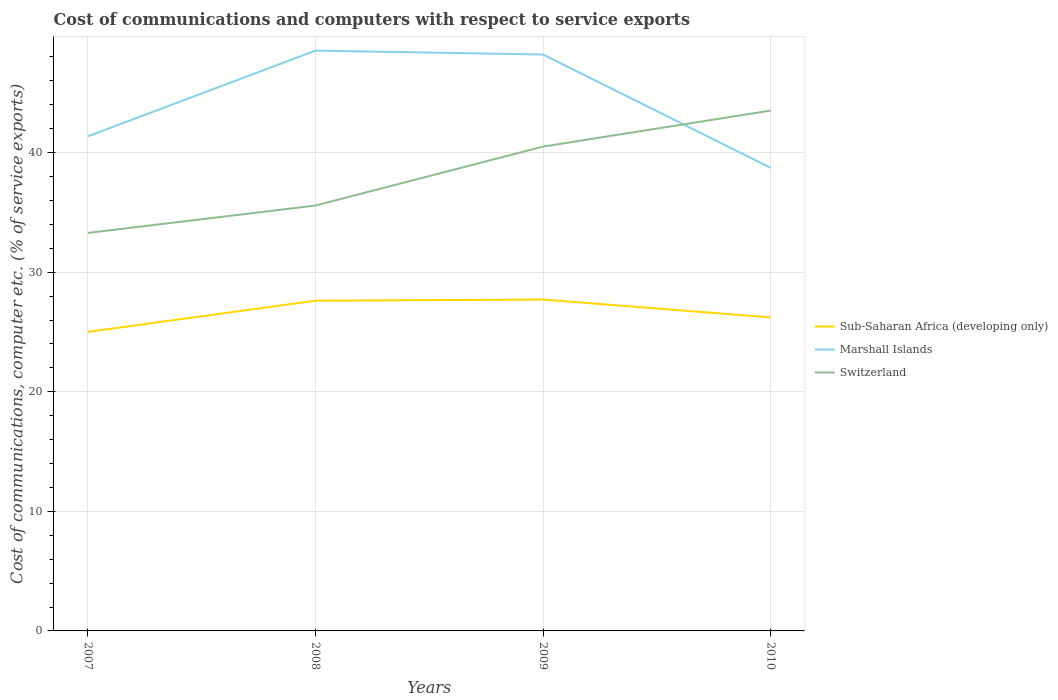How many different coloured lines are there?
Offer a terse response. 3. Across all years, what is the maximum cost of communications and computers in Sub-Saharan Africa (developing only)?
Make the answer very short. 25.01. In which year was the cost of communications and computers in Switzerland maximum?
Your answer should be compact. 2007. What is the total cost of communications and computers in Marshall Islands in the graph?
Give a very brief answer. 9.48. What is the difference between the highest and the second highest cost of communications and computers in Switzerland?
Offer a very short reply. 10.23. What is the difference between the highest and the lowest cost of communications and computers in Switzerland?
Your answer should be very brief. 2. Is the cost of communications and computers in Marshall Islands strictly greater than the cost of communications and computers in Switzerland over the years?
Give a very brief answer. No. How many lines are there?
Provide a short and direct response. 3. How many years are there in the graph?
Offer a very short reply. 4. What is the difference between two consecutive major ticks on the Y-axis?
Provide a short and direct response. 10. Does the graph contain any zero values?
Provide a succinct answer. No. How many legend labels are there?
Make the answer very short. 3. What is the title of the graph?
Give a very brief answer. Cost of communications and computers with respect to service exports. What is the label or title of the X-axis?
Provide a succinct answer. Years. What is the label or title of the Y-axis?
Keep it short and to the point. Cost of communications, computer etc. (% of service exports). What is the Cost of communications, computer etc. (% of service exports) of Sub-Saharan Africa (developing only) in 2007?
Your response must be concise. 25.01. What is the Cost of communications, computer etc. (% of service exports) in Marshall Islands in 2007?
Offer a very short reply. 41.36. What is the Cost of communications, computer etc. (% of service exports) in Switzerland in 2007?
Your answer should be very brief. 33.29. What is the Cost of communications, computer etc. (% of service exports) in Sub-Saharan Africa (developing only) in 2008?
Offer a very short reply. 27.62. What is the Cost of communications, computer etc. (% of service exports) in Marshall Islands in 2008?
Your answer should be very brief. 48.53. What is the Cost of communications, computer etc. (% of service exports) of Switzerland in 2008?
Give a very brief answer. 35.58. What is the Cost of communications, computer etc. (% of service exports) of Sub-Saharan Africa (developing only) in 2009?
Provide a short and direct response. 27.71. What is the Cost of communications, computer etc. (% of service exports) of Marshall Islands in 2009?
Your answer should be compact. 48.2. What is the Cost of communications, computer etc. (% of service exports) of Switzerland in 2009?
Provide a short and direct response. 40.51. What is the Cost of communications, computer etc. (% of service exports) of Sub-Saharan Africa (developing only) in 2010?
Offer a terse response. 26.22. What is the Cost of communications, computer etc. (% of service exports) in Marshall Islands in 2010?
Your answer should be very brief. 38.73. What is the Cost of communications, computer etc. (% of service exports) of Switzerland in 2010?
Provide a short and direct response. 43.52. Across all years, what is the maximum Cost of communications, computer etc. (% of service exports) of Sub-Saharan Africa (developing only)?
Give a very brief answer. 27.71. Across all years, what is the maximum Cost of communications, computer etc. (% of service exports) of Marshall Islands?
Make the answer very short. 48.53. Across all years, what is the maximum Cost of communications, computer etc. (% of service exports) in Switzerland?
Ensure brevity in your answer.  43.52. Across all years, what is the minimum Cost of communications, computer etc. (% of service exports) of Sub-Saharan Africa (developing only)?
Your response must be concise. 25.01. Across all years, what is the minimum Cost of communications, computer etc. (% of service exports) in Marshall Islands?
Provide a short and direct response. 38.73. Across all years, what is the minimum Cost of communications, computer etc. (% of service exports) in Switzerland?
Offer a terse response. 33.29. What is the total Cost of communications, computer etc. (% of service exports) of Sub-Saharan Africa (developing only) in the graph?
Provide a succinct answer. 106.56. What is the total Cost of communications, computer etc. (% of service exports) in Marshall Islands in the graph?
Make the answer very short. 176.83. What is the total Cost of communications, computer etc. (% of service exports) of Switzerland in the graph?
Offer a terse response. 152.89. What is the difference between the Cost of communications, computer etc. (% of service exports) in Sub-Saharan Africa (developing only) in 2007 and that in 2008?
Provide a short and direct response. -2.61. What is the difference between the Cost of communications, computer etc. (% of service exports) of Marshall Islands in 2007 and that in 2008?
Give a very brief answer. -7.17. What is the difference between the Cost of communications, computer etc. (% of service exports) in Switzerland in 2007 and that in 2008?
Offer a very short reply. -2.29. What is the difference between the Cost of communications, computer etc. (% of service exports) of Sub-Saharan Africa (developing only) in 2007 and that in 2009?
Your answer should be compact. -2.71. What is the difference between the Cost of communications, computer etc. (% of service exports) in Marshall Islands in 2007 and that in 2009?
Your answer should be compact. -6.84. What is the difference between the Cost of communications, computer etc. (% of service exports) of Switzerland in 2007 and that in 2009?
Provide a succinct answer. -7.22. What is the difference between the Cost of communications, computer etc. (% of service exports) of Sub-Saharan Africa (developing only) in 2007 and that in 2010?
Ensure brevity in your answer.  -1.21. What is the difference between the Cost of communications, computer etc. (% of service exports) of Marshall Islands in 2007 and that in 2010?
Your answer should be very brief. 2.63. What is the difference between the Cost of communications, computer etc. (% of service exports) of Switzerland in 2007 and that in 2010?
Your response must be concise. -10.23. What is the difference between the Cost of communications, computer etc. (% of service exports) of Sub-Saharan Africa (developing only) in 2008 and that in 2009?
Your answer should be compact. -0.1. What is the difference between the Cost of communications, computer etc. (% of service exports) of Marshall Islands in 2008 and that in 2009?
Give a very brief answer. 0.33. What is the difference between the Cost of communications, computer etc. (% of service exports) in Switzerland in 2008 and that in 2009?
Make the answer very short. -4.93. What is the difference between the Cost of communications, computer etc. (% of service exports) of Sub-Saharan Africa (developing only) in 2008 and that in 2010?
Keep it short and to the point. 1.4. What is the difference between the Cost of communications, computer etc. (% of service exports) of Marshall Islands in 2008 and that in 2010?
Provide a short and direct response. 9.8. What is the difference between the Cost of communications, computer etc. (% of service exports) of Switzerland in 2008 and that in 2010?
Keep it short and to the point. -7.94. What is the difference between the Cost of communications, computer etc. (% of service exports) of Sub-Saharan Africa (developing only) in 2009 and that in 2010?
Provide a succinct answer. 1.5. What is the difference between the Cost of communications, computer etc. (% of service exports) in Marshall Islands in 2009 and that in 2010?
Your answer should be very brief. 9.48. What is the difference between the Cost of communications, computer etc. (% of service exports) of Switzerland in 2009 and that in 2010?
Your answer should be compact. -3.01. What is the difference between the Cost of communications, computer etc. (% of service exports) in Sub-Saharan Africa (developing only) in 2007 and the Cost of communications, computer etc. (% of service exports) in Marshall Islands in 2008?
Your response must be concise. -23.52. What is the difference between the Cost of communications, computer etc. (% of service exports) in Sub-Saharan Africa (developing only) in 2007 and the Cost of communications, computer etc. (% of service exports) in Switzerland in 2008?
Provide a succinct answer. -10.57. What is the difference between the Cost of communications, computer etc. (% of service exports) in Marshall Islands in 2007 and the Cost of communications, computer etc. (% of service exports) in Switzerland in 2008?
Provide a short and direct response. 5.79. What is the difference between the Cost of communications, computer etc. (% of service exports) of Sub-Saharan Africa (developing only) in 2007 and the Cost of communications, computer etc. (% of service exports) of Marshall Islands in 2009?
Your answer should be compact. -23.2. What is the difference between the Cost of communications, computer etc. (% of service exports) of Sub-Saharan Africa (developing only) in 2007 and the Cost of communications, computer etc. (% of service exports) of Switzerland in 2009?
Ensure brevity in your answer.  -15.5. What is the difference between the Cost of communications, computer etc. (% of service exports) of Marshall Islands in 2007 and the Cost of communications, computer etc. (% of service exports) of Switzerland in 2009?
Offer a very short reply. 0.86. What is the difference between the Cost of communications, computer etc. (% of service exports) in Sub-Saharan Africa (developing only) in 2007 and the Cost of communications, computer etc. (% of service exports) in Marshall Islands in 2010?
Your answer should be very brief. -13.72. What is the difference between the Cost of communications, computer etc. (% of service exports) of Sub-Saharan Africa (developing only) in 2007 and the Cost of communications, computer etc. (% of service exports) of Switzerland in 2010?
Your response must be concise. -18.51. What is the difference between the Cost of communications, computer etc. (% of service exports) of Marshall Islands in 2007 and the Cost of communications, computer etc. (% of service exports) of Switzerland in 2010?
Keep it short and to the point. -2.16. What is the difference between the Cost of communications, computer etc. (% of service exports) in Sub-Saharan Africa (developing only) in 2008 and the Cost of communications, computer etc. (% of service exports) in Marshall Islands in 2009?
Give a very brief answer. -20.59. What is the difference between the Cost of communications, computer etc. (% of service exports) in Sub-Saharan Africa (developing only) in 2008 and the Cost of communications, computer etc. (% of service exports) in Switzerland in 2009?
Your response must be concise. -12.89. What is the difference between the Cost of communications, computer etc. (% of service exports) in Marshall Islands in 2008 and the Cost of communications, computer etc. (% of service exports) in Switzerland in 2009?
Give a very brief answer. 8.02. What is the difference between the Cost of communications, computer etc. (% of service exports) of Sub-Saharan Africa (developing only) in 2008 and the Cost of communications, computer etc. (% of service exports) of Marshall Islands in 2010?
Provide a short and direct response. -11.11. What is the difference between the Cost of communications, computer etc. (% of service exports) of Sub-Saharan Africa (developing only) in 2008 and the Cost of communications, computer etc. (% of service exports) of Switzerland in 2010?
Your answer should be very brief. -15.9. What is the difference between the Cost of communications, computer etc. (% of service exports) in Marshall Islands in 2008 and the Cost of communications, computer etc. (% of service exports) in Switzerland in 2010?
Provide a succinct answer. 5.01. What is the difference between the Cost of communications, computer etc. (% of service exports) in Sub-Saharan Africa (developing only) in 2009 and the Cost of communications, computer etc. (% of service exports) in Marshall Islands in 2010?
Your answer should be compact. -11.01. What is the difference between the Cost of communications, computer etc. (% of service exports) in Sub-Saharan Africa (developing only) in 2009 and the Cost of communications, computer etc. (% of service exports) in Switzerland in 2010?
Your answer should be compact. -15.8. What is the difference between the Cost of communications, computer etc. (% of service exports) of Marshall Islands in 2009 and the Cost of communications, computer etc. (% of service exports) of Switzerland in 2010?
Provide a succinct answer. 4.69. What is the average Cost of communications, computer etc. (% of service exports) in Sub-Saharan Africa (developing only) per year?
Give a very brief answer. 26.64. What is the average Cost of communications, computer etc. (% of service exports) of Marshall Islands per year?
Your answer should be compact. 44.21. What is the average Cost of communications, computer etc. (% of service exports) of Switzerland per year?
Your answer should be very brief. 38.22. In the year 2007, what is the difference between the Cost of communications, computer etc. (% of service exports) in Sub-Saharan Africa (developing only) and Cost of communications, computer etc. (% of service exports) in Marshall Islands?
Your response must be concise. -16.35. In the year 2007, what is the difference between the Cost of communications, computer etc. (% of service exports) in Sub-Saharan Africa (developing only) and Cost of communications, computer etc. (% of service exports) in Switzerland?
Your response must be concise. -8.28. In the year 2007, what is the difference between the Cost of communications, computer etc. (% of service exports) of Marshall Islands and Cost of communications, computer etc. (% of service exports) of Switzerland?
Provide a succinct answer. 8.08. In the year 2008, what is the difference between the Cost of communications, computer etc. (% of service exports) in Sub-Saharan Africa (developing only) and Cost of communications, computer etc. (% of service exports) in Marshall Islands?
Provide a succinct answer. -20.91. In the year 2008, what is the difference between the Cost of communications, computer etc. (% of service exports) of Sub-Saharan Africa (developing only) and Cost of communications, computer etc. (% of service exports) of Switzerland?
Your response must be concise. -7.96. In the year 2008, what is the difference between the Cost of communications, computer etc. (% of service exports) of Marshall Islands and Cost of communications, computer etc. (% of service exports) of Switzerland?
Make the answer very short. 12.95. In the year 2009, what is the difference between the Cost of communications, computer etc. (% of service exports) in Sub-Saharan Africa (developing only) and Cost of communications, computer etc. (% of service exports) in Marshall Islands?
Offer a very short reply. -20.49. In the year 2009, what is the difference between the Cost of communications, computer etc. (% of service exports) of Sub-Saharan Africa (developing only) and Cost of communications, computer etc. (% of service exports) of Switzerland?
Ensure brevity in your answer.  -12.79. In the year 2009, what is the difference between the Cost of communications, computer etc. (% of service exports) in Marshall Islands and Cost of communications, computer etc. (% of service exports) in Switzerland?
Give a very brief answer. 7.7. In the year 2010, what is the difference between the Cost of communications, computer etc. (% of service exports) of Sub-Saharan Africa (developing only) and Cost of communications, computer etc. (% of service exports) of Marshall Islands?
Give a very brief answer. -12.51. In the year 2010, what is the difference between the Cost of communications, computer etc. (% of service exports) of Sub-Saharan Africa (developing only) and Cost of communications, computer etc. (% of service exports) of Switzerland?
Provide a short and direct response. -17.3. In the year 2010, what is the difference between the Cost of communications, computer etc. (% of service exports) of Marshall Islands and Cost of communications, computer etc. (% of service exports) of Switzerland?
Make the answer very short. -4.79. What is the ratio of the Cost of communications, computer etc. (% of service exports) in Sub-Saharan Africa (developing only) in 2007 to that in 2008?
Your answer should be compact. 0.91. What is the ratio of the Cost of communications, computer etc. (% of service exports) in Marshall Islands in 2007 to that in 2008?
Give a very brief answer. 0.85. What is the ratio of the Cost of communications, computer etc. (% of service exports) of Switzerland in 2007 to that in 2008?
Offer a terse response. 0.94. What is the ratio of the Cost of communications, computer etc. (% of service exports) of Sub-Saharan Africa (developing only) in 2007 to that in 2009?
Provide a succinct answer. 0.9. What is the ratio of the Cost of communications, computer etc. (% of service exports) of Marshall Islands in 2007 to that in 2009?
Your answer should be very brief. 0.86. What is the ratio of the Cost of communications, computer etc. (% of service exports) in Switzerland in 2007 to that in 2009?
Give a very brief answer. 0.82. What is the ratio of the Cost of communications, computer etc. (% of service exports) in Sub-Saharan Africa (developing only) in 2007 to that in 2010?
Make the answer very short. 0.95. What is the ratio of the Cost of communications, computer etc. (% of service exports) in Marshall Islands in 2007 to that in 2010?
Offer a very short reply. 1.07. What is the ratio of the Cost of communications, computer etc. (% of service exports) of Switzerland in 2007 to that in 2010?
Ensure brevity in your answer.  0.76. What is the ratio of the Cost of communications, computer etc. (% of service exports) in Sub-Saharan Africa (developing only) in 2008 to that in 2009?
Make the answer very short. 1. What is the ratio of the Cost of communications, computer etc. (% of service exports) in Marshall Islands in 2008 to that in 2009?
Provide a short and direct response. 1.01. What is the ratio of the Cost of communications, computer etc. (% of service exports) of Switzerland in 2008 to that in 2009?
Offer a terse response. 0.88. What is the ratio of the Cost of communications, computer etc. (% of service exports) of Sub-Saharan Africa (developing only) in 2008 to that in 2010?
Ensure brevity in your answer.  1.05. What is the ratio of the Cost of communications, computer etc. (% of service exports) in Marshall Islands in 2008 to that in 2010?
Your answer should be compact. 1.25. What is the ratio of the Cost of communications, computer etc. (% of service exports) of Switzerland in 2008 to that in 2010?
Make the answer very short. 0.82. What is the ratio of the Cost of communications, computer etc. (% of service exports) in Sub-Saharan Africa (developing only) in 2009 to that in 2010?
Offer a terse response. 1.06. What is the ratio of the Cost of communications, computer etc. (% of service exports) of Marshall Islands in 2009 to that in 2010?
Keep it short and to the point. 1.24. What is the ratio of the Cost of communications, computer etc. (% of service exports) in Switzerland in 2009 to that in 2010?
Keep it short and to the point. 0.93. What is the difference between the highest and the second highest Cost of communications, computer etc. (% of service exports) of Sub-Saharan Africa (developing only)?
Your answer should be very brief. 0.1. What is the difference between the highest and the second highest Cost of communications, computer etc. (% of service exports) in Marshall Islands?
Make the answer very short. 0.33. What is the difference between the highest and the second highest Cost of communications, computer etc. (% of service exports) of Switzerland?
Offer a terse response. 3.01. What is the difference between the highest and the lowest Cost of communications, computer etc. (% of service exports) in Sub-Saharan Africa (developing only)?
Offer a very short reply. 2.71. What is the difference between the highest and the lowest Cost of communications, computer etc. (% of service exports) of Marshall Islands?
Your answer should be very brief. 9.8. What is the difference between the highest and the lowest Cost of communications, computer etc. (% of service exports) in Switzerland?
Offer a very short reply. 10.23. 